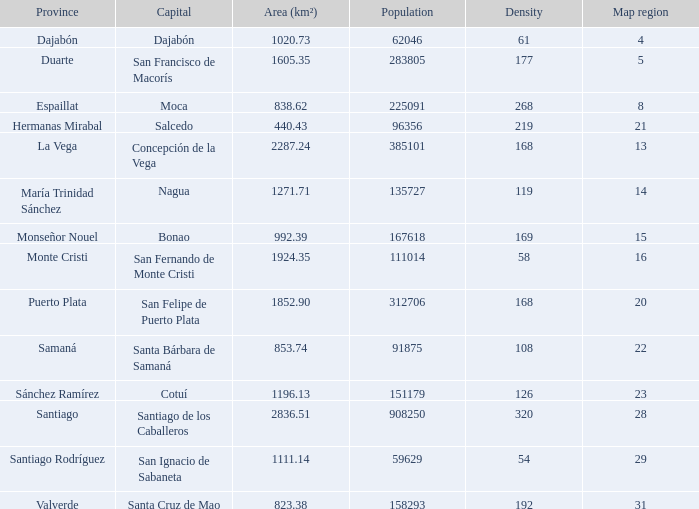When province is monseñor nouel, what is the area (km²)? 992.39. 